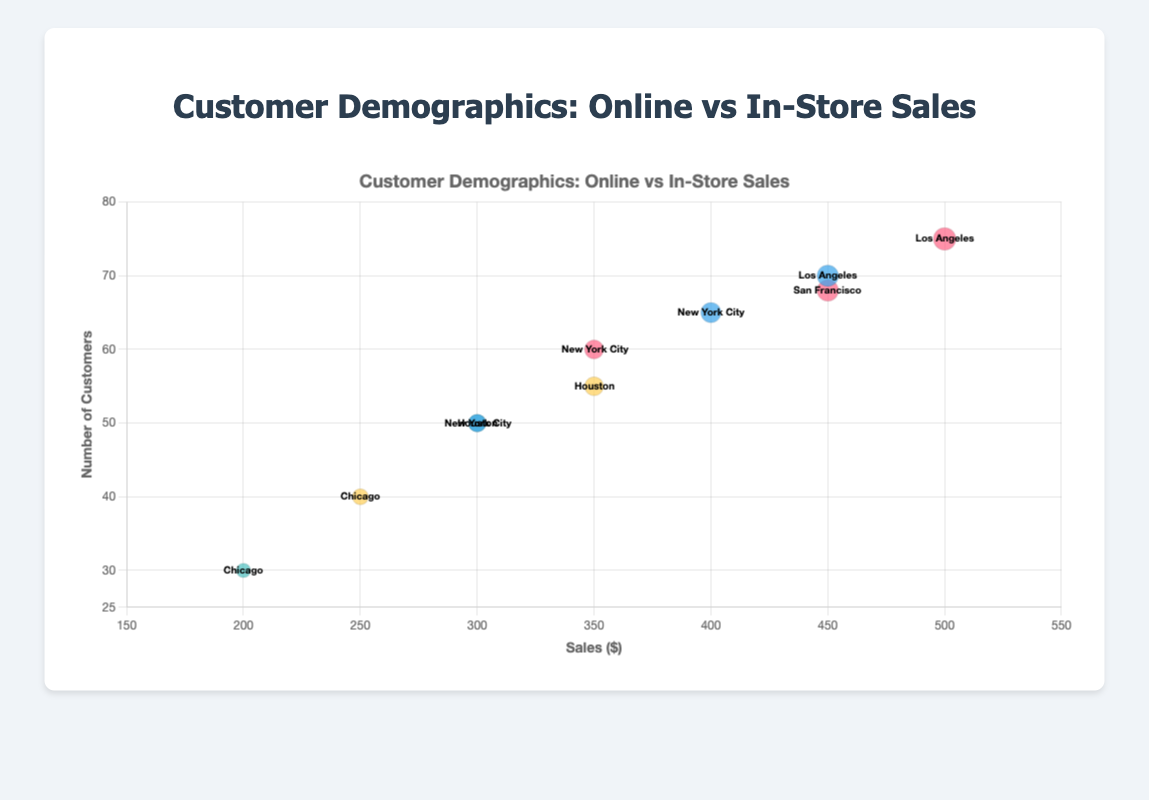How many in-store sales data points are there in the chart? The figure displays the number of data points for each category and you can tell by looking at the labels that four data points correspond to in-store sales.
Answer: 4 Which location has the highest number of online customer counts within the age range of 25-34? To determine this, we check all the data points that fall under the age range 25-34 for online sales. In these datasets, Los Angeles has the highest number with 75 online customers for females.
Answer: Los Angeles Compare the sales for male customers aged 18-24 in online versus in-store categories. Which category has higher sales? The figure shows a data point for online male customers aged 18-24 with 300 sales in New York City, and a data point for in-store male customers aged 18-24 with 200 sales in Chicago. 300 online sales is higher than 200 in-store sales.
Answer: Online What is the bubble radius on the chart for an online female customer in Los Angeles aged 25-34? The radius of a bubble in a bubble chart is usually proportional to the measure of a particular attribute, which in this case is sales. The formula provided in the code demonstrates it is the sales amount divided by 2. For 500 sales, it's divided by 2, yielding a radius of √500 / 2 ≈ 11.18.
Answer: ~11.18 Which gender shows higher sales for online customers aged 35-44 in New York City? In the 35-44 age range for online customers in New York City, there is one data point for males with 400 sales. Females in this age range and location are not depicted in the chart, suggesting males have higher sales.
Answer: Male How do the number of female customers compare between in-store and online sales for the 18-24 age range? The chart displays 60 online female customers aged 18-24 in New York City, and 40 in-store female customers aged 18-24 in Chicago. There are more female customers in the online category.
Answer: More customers online What's the combined sales for all online customers aged 18-24? There are two data points for online customers aged 18-24: males with 300 sales and females with 350 sales. The combined sales are 300 + 350 = 650.
Answer: 650 What is the location for the customer bubble in the chart that has the highest number of sales? By examining the sales values, we identify the highest number is 500, which corresponds to online females aged 25-34 in Los Angeles.
Answer: Los Angeles How do the number of in-store customers in the 25-34 age range compare across Houston and Chicago? The figure only has in-store sales data for this age range in Houston, with 50 male and 55 female customers. There is no in-store data for Chicago in this range.
Answer: Houston only 